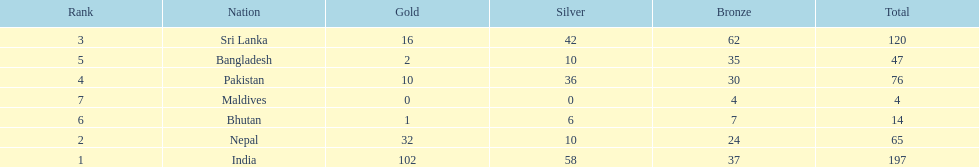Parse the full table. {'header': ['Rank', 'Nation', 'Gold', 'Silver', 'Bronze', 'Total'], 'rows': [['3', 'Sri Lanka', '16', '42', '62', '120'], ['5', 'Bangladesh', '2', '10', '35', '47'], ['4', 'Pakistan', '10', '36', '30', '76'], ['7', 'Maldives', '0', '0', '4', '4'], ['6', 'Bhutan', '1', '6', '7', '14'], ['2', 'Nepal', '32', '10', '24', '65'], ['1', 'India', '102', '58', '37', '197']]} How many gold medals did india win? 102. 